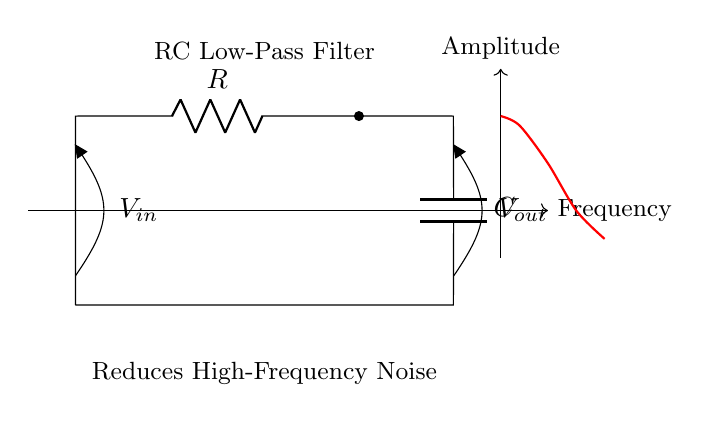What type of components are used in this circuit? The circuit contains a resistor and a capacitor, which are the primary components in an RC low-pass filter. The diagram specifically labels these components as R for resistor and C for capacitor.
Answer: resistor and capacitor What is the purpose of the circuit? The circuit's purpose is to reduce high-frequency noise in audio systems, as indicated by the label "Reduces High-Frequency Noise." This illustrates that the filter allows lower frequencies to pass while attenuating higher frequencies.
Answer: reduces noise What is the position of the input voltage in the circuit? The input voltage, labeled V in, is located at the top left of the diagram, indicating where the voltage is applied. Specifically, it is connected to the point before the resistor, making it the entrance of the circuit.
Answer: top left How many terminals does the capacitor have? The capacitor has two terminals: one connected to the output and the other connected to the ground as per the configuration in this circuit. Each of these terminals represents a point of electrical connection essential for the capacitor's function.
Answer: two At which point is the output voltage measured? The output voltage, labeled V out, is measured across the capacitor, indicating it is taken from the point where the capacitor connects to the circuit just before it returns to ground, showcasing the filtered signal.
Answer: across the capacitor What happens to high-frequency signals in this circuit? High-frequency signals are attenuated or reduced as they pass through the RC low-pass filter; this is because the capacitor blocks high-frequency signals while allowing low frequencies to pass through more easily.
Answer: attenuated What role does the resistor play in this circuit? The resistor limits the current in the circuit and works together with the capacitor to determine the cutoff frequency of the filter, thus influencing how signals of different frequencies will be allowed through. The resistor is vital for controlling the charging and discharging behavior of the capacitor.
Answer: limits current 